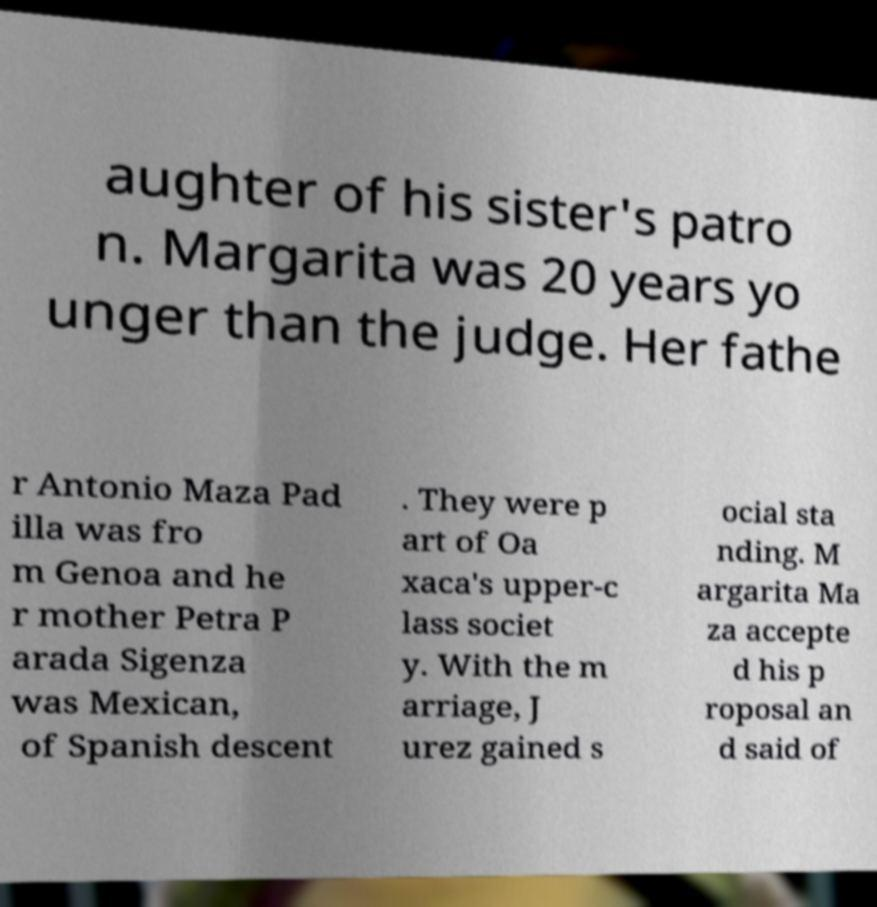I need the written content from this picture converted into text. Can you do that? aughter of his sister's patro n. Margarita was 20 years yo unger than the judge. Her fathe r Antonio Maza Pad illa was fro m Genoa and he r mother Petra P arada Sigenza was Mexican, of Spanish descent . They were p art of Oa xaca's upper-c lass societ y. With the m arriage, J urez gained s ocial sta nding. M argarita Ma za accepte d his p roposal an d said of 